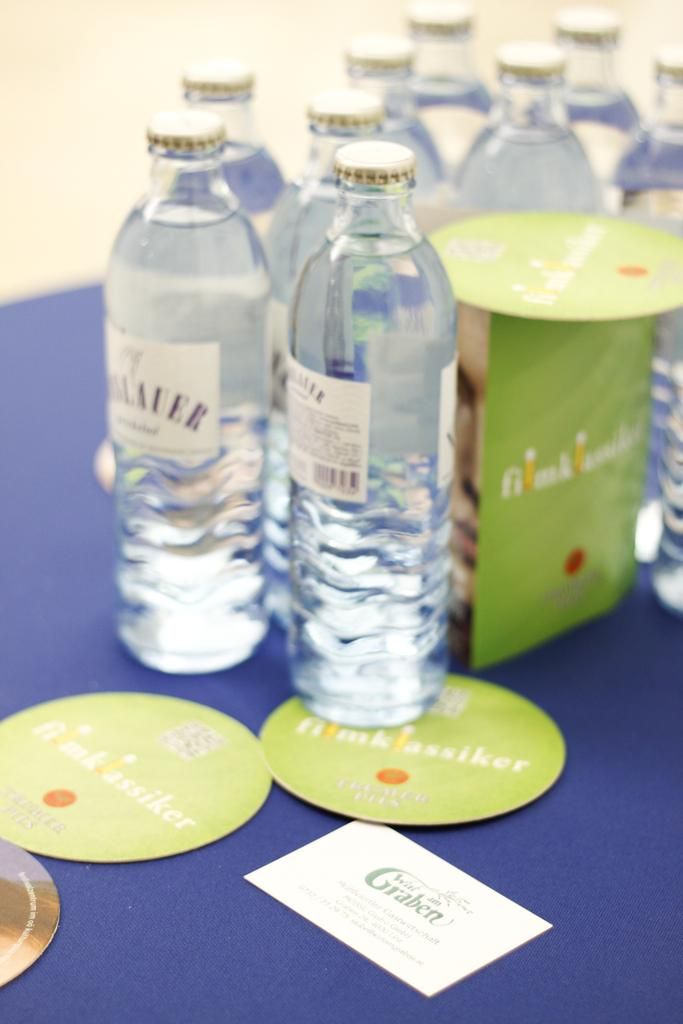What objects can be seen on the floor in the image? There are bottles and cards placed on the floor in the image. Can you describe the objects in more detail? The objects are bottles and cards. What is the position of the bottles and cards in relation to each other? The bottles and cards are placed on the floor together. What type of railway is visible in the image? There is no railway present in the image; it only features bottles and cards placed on the floor. 